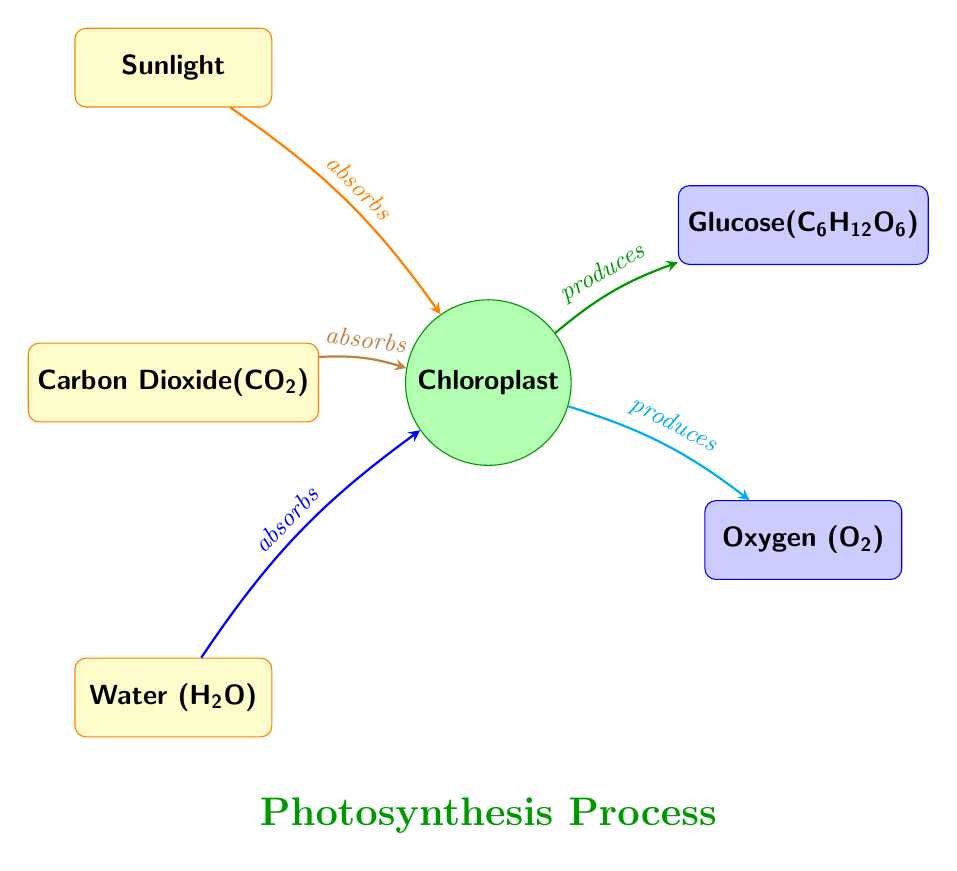What are the inputs to the chloroplast? The diagram shows three inputs to the chloroplast, which are Sunlight, Carbon Dioxide, and Water. Each input is represented in the diagram with labeled nodes.
Answer: Sunlight, Carbon Dioxide, Water How many output nodes are present in the diagram? There are two output nodes depicted in the diagram: Glucose and Oxygen. A simple count of nodes in the output section shows this.
Answer: 2 What process occurs in the chloroplast? The chloroplast node in the diagram is labeled clearly as the location where photosynthesis occurs. This indicates the process taking place within it.
Answer: Photosynthesis What does sunlight do in the diagram? The arrow labeled "absorbs" connects the Sunlight input node to the chloroplast, indicating that sunlight is absorbed to fuel the process occurring in the chloroplast.
Answer: Absorbs What is produced from the chloroplast besides glucose? The chloroplast also produces Oxygen, as indicated by the output node connected to it with an arrow labeled "produces". This shows that both glucose and oxygen are results of the photosynthesis process.
Answer: Oxygen Which component absorbs carbon dioxide? The arrow from the Carbon Dioxide node points toward the chloroplast, indicating that this is the component that absorbs carbon dioxide during the photosynthesis process.
Answer: Chloroplast How does water contribute to the photosynthesis process? The diagram shows that water is absorbed by the chloroplast, similar to how sunlight and carbon dioxide are processed. The arrow labeled "absorbs" leading from the water node to the chloroplast indicates this contribution.
Answer: Absorbs Which input has a direct influence on producing glucose? The chloroplast node shows that both sunlight and carbon dioxide are absorbed and lead to the production of glucose. Thus, the inputs that influence glucose production directly include these two elements.
Answer: Sunlight, Carbon Dioxide 